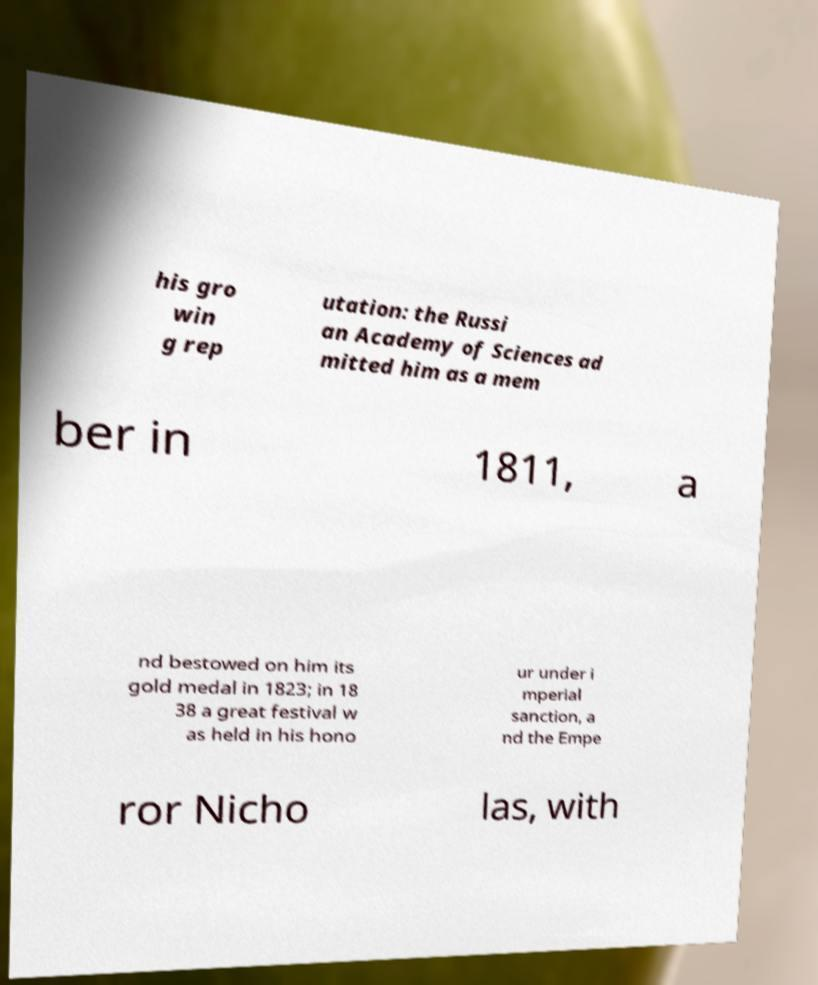For documentation purposes, I need the text within this image transcribed. Could you provide that? his gro win g rep utation: the Russi an Academy of Sciences ad mitted him as a mem ber in 1811, a nd bestowed on him its gold medal in 1823; in 18 38 a great festival w as held in his hono ur under i mperial sanction, a nd the Empe ror Nicho las, with 